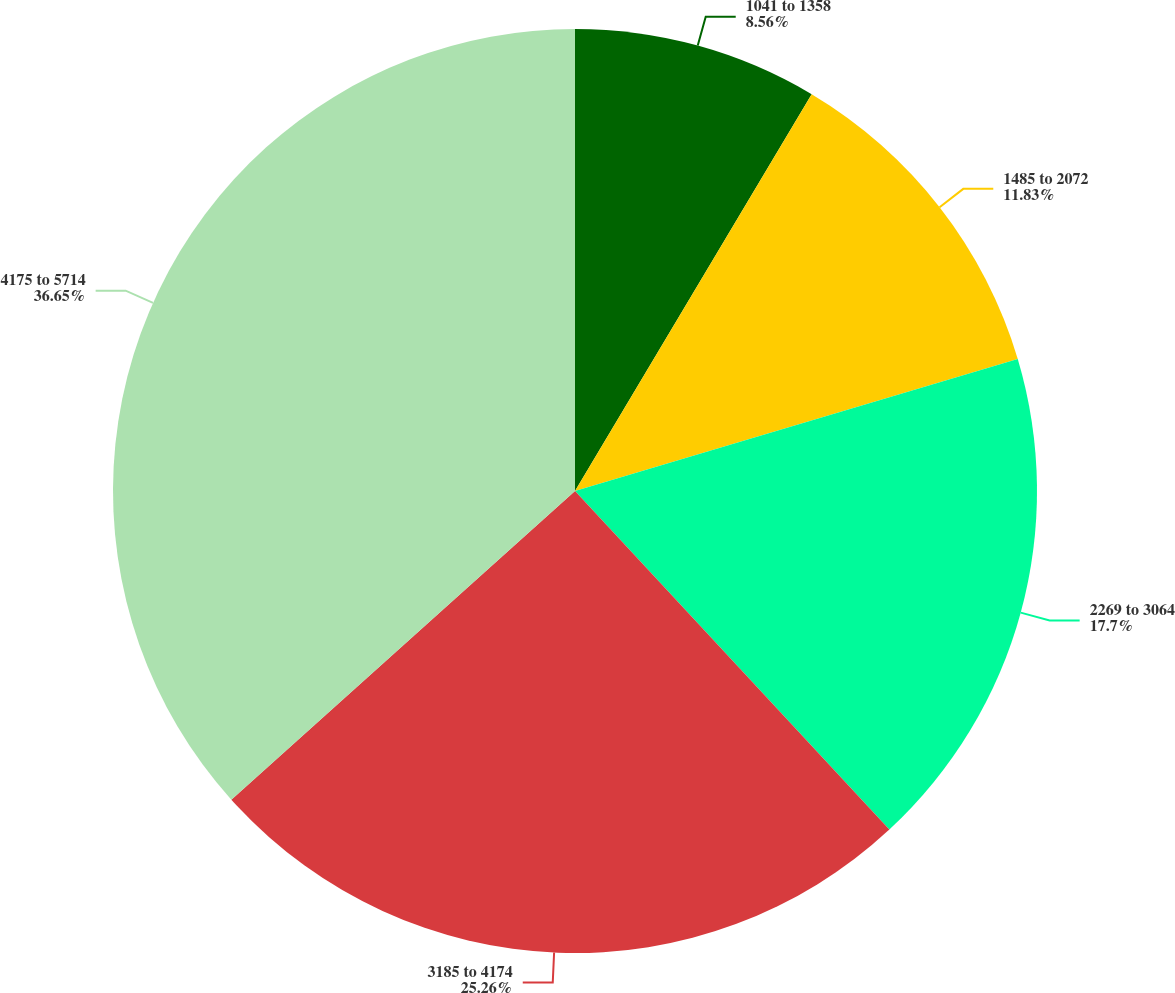Convert chart. <chart><loc_0><loc_0><loc_500><loc_500><pie_chart><fcel>1041 to 1358<fcel>1485 to 2072<fcel>2269 to 3064<fcel>3185 to 4174<fcel>4175 to 5714<nl><fcel>8.56%<fcel>11.83%<fcel>17.7%<fcel>25.26%<fcel>36.65%<nl></chart> 